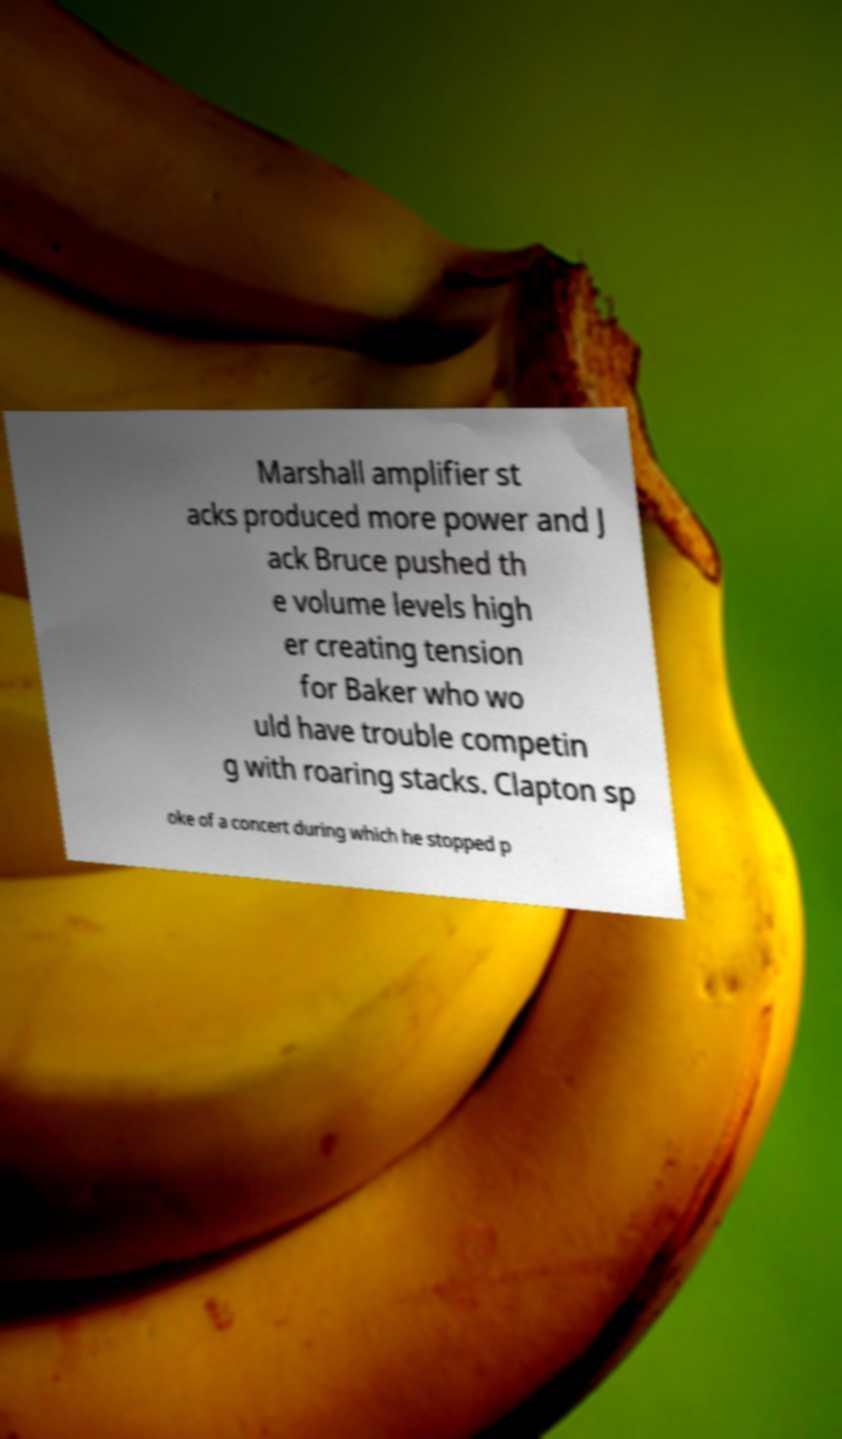For documentation purposes, I need the text within this image transcribed. Could you provide that? Marshall amplifier st acks produced more power and J ack Bruce pushed th e volume levels high er creating tension for Baker who wo uld have trouble competin g with roaring stacks. Clapton sp oke of a concert during which he stopped p 